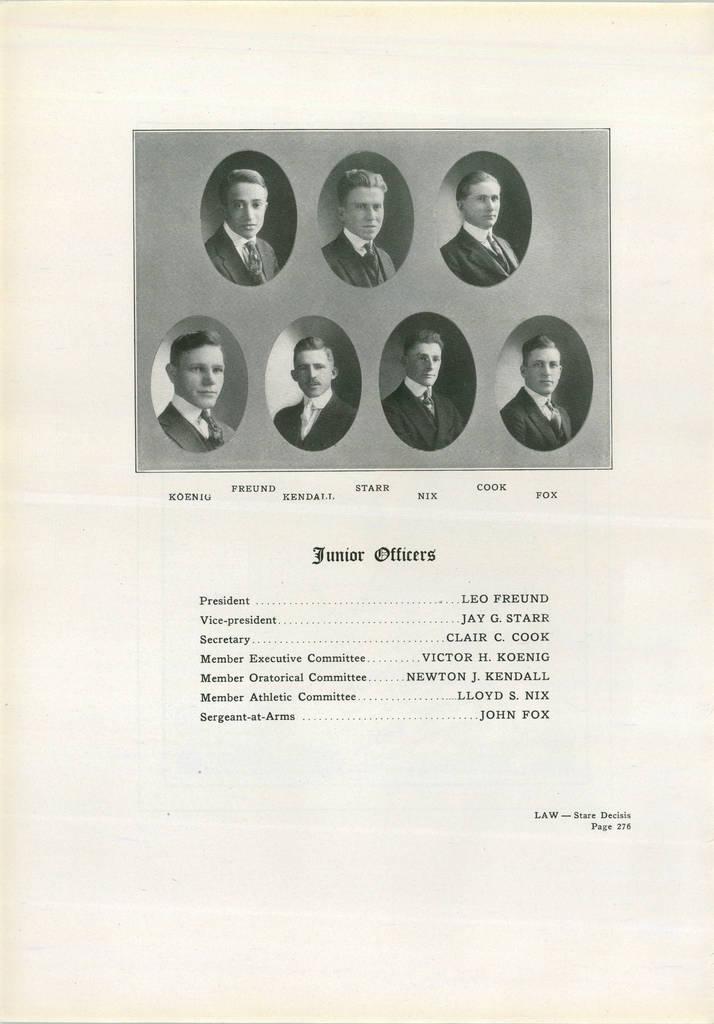In one or two sentences, can you explain what this image depicts? This image looks like a printed image, in which I can see a text and seven persons photo. 